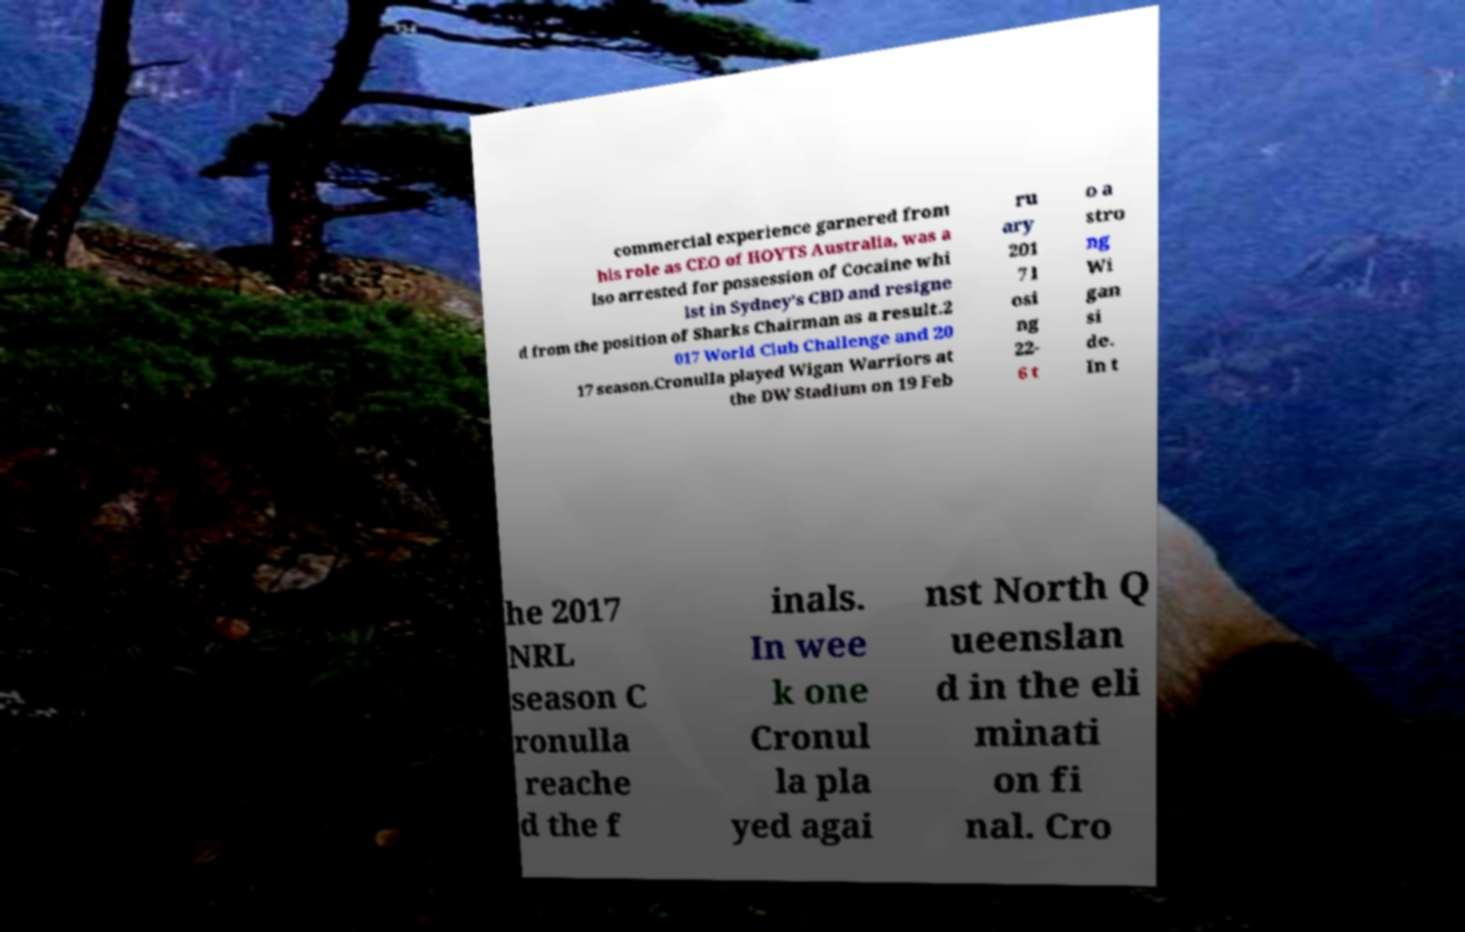Can you accurately transcribe the text from the provided image for me? commercial experience garnered from his role as CEO of HOYTS Australia, was a lso arrested for possession of Cocaine whi lst in Sydney's CBD and resigne d from the position of Sharks Chairman as a result.2 017 World Club Challenge and 20 17 season.Cronulla played Wigan Warriors at the DW Stadium on 19 Feb ru ary 201 7 l osi ng 22- 6 t o a stro ng Wi gan si de. In t he 2017 NRL season C ronulla reache d the f inals. In wee k one Cronul la pla yed agai nst North Q ueenslan d in the eli minati on fi nal. Cro 